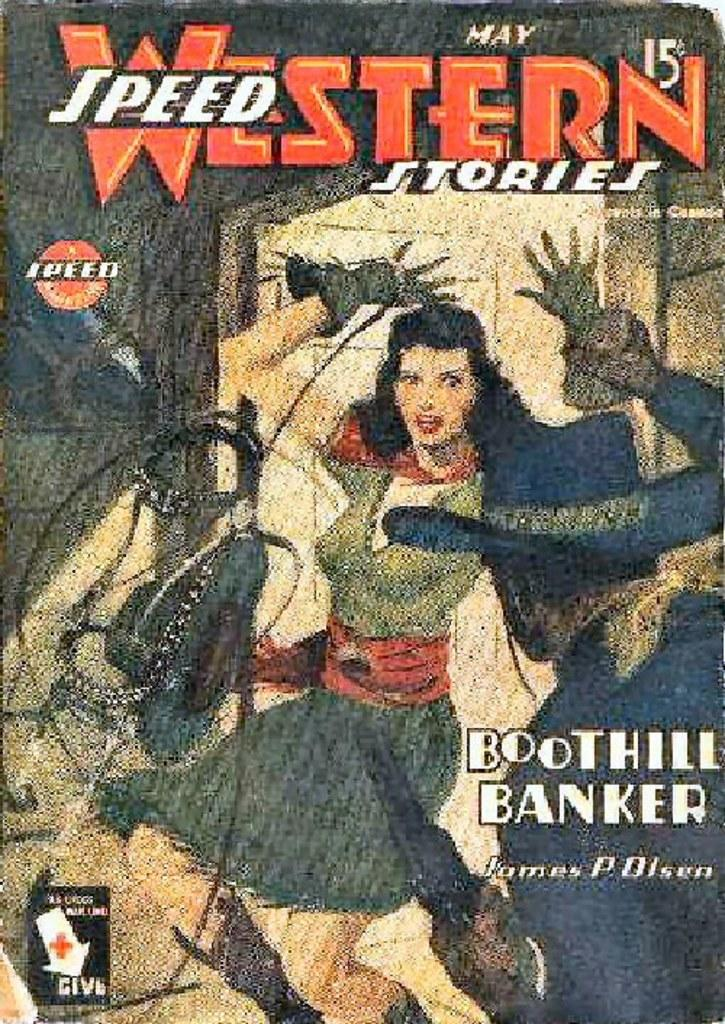<image>
Present a compact description of the photo's key features. Poster showing a woman with her arms up and the title "Western Speed Stories". 